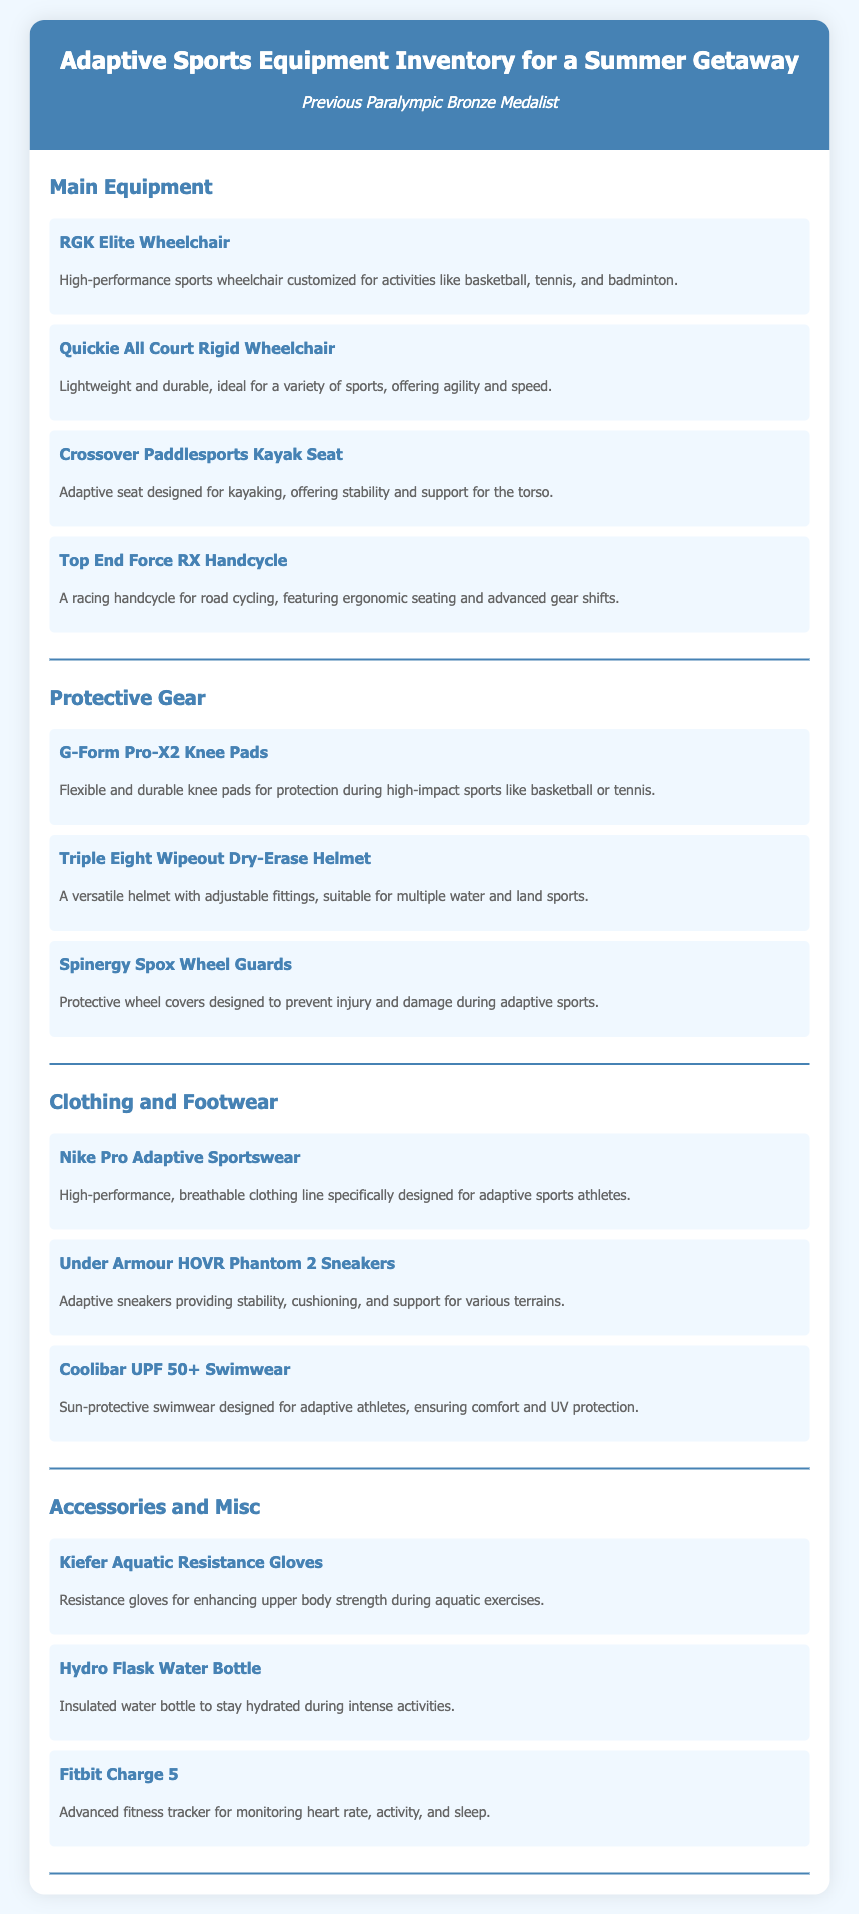what is the title of the document? The title appears prominently at the top of the document.
Answer: Adaptive Sports Equipment Inventory for a Summer Getaway how many different categories of equipment are listed? The document contains four distinct categories of equipment.
Answer: 4 what type of wheelchair is mentioned under Main Equipment? The document lists specific types of wheelchairs in the Main Equipment section.
Answer: RGK Elite Wheelchair which brand of sneakers is included in the Clothing and Footwear category? The Clothing and Footwear section specifies a particular brand of sneakers.
Answer: Under Armour what is the description of the G-Form Pro-X2 Knee Pads? The document provides a brief description of each item, including these knee pads.
Answer: Flexible and durable knee pads for protection during high-impact sports like basketball or tennis which item in the Accessories and Misc category helps with hydration? The document lists items relevant to hydration under this category.
Answer: Hydro Flask Water Bottle how does the Triple Eight Wipeout Dry-Erase Helmet fit? The document describes specific features of the helmet regarding its fit.
Answer: Adjustable fittings what is the main function of Kiefer Aquatic Resistance Gloves? The document details the purpose of these gloves within the context of adaptive sports.
Answer: Enhancing upper body strength during aquatic exercises 